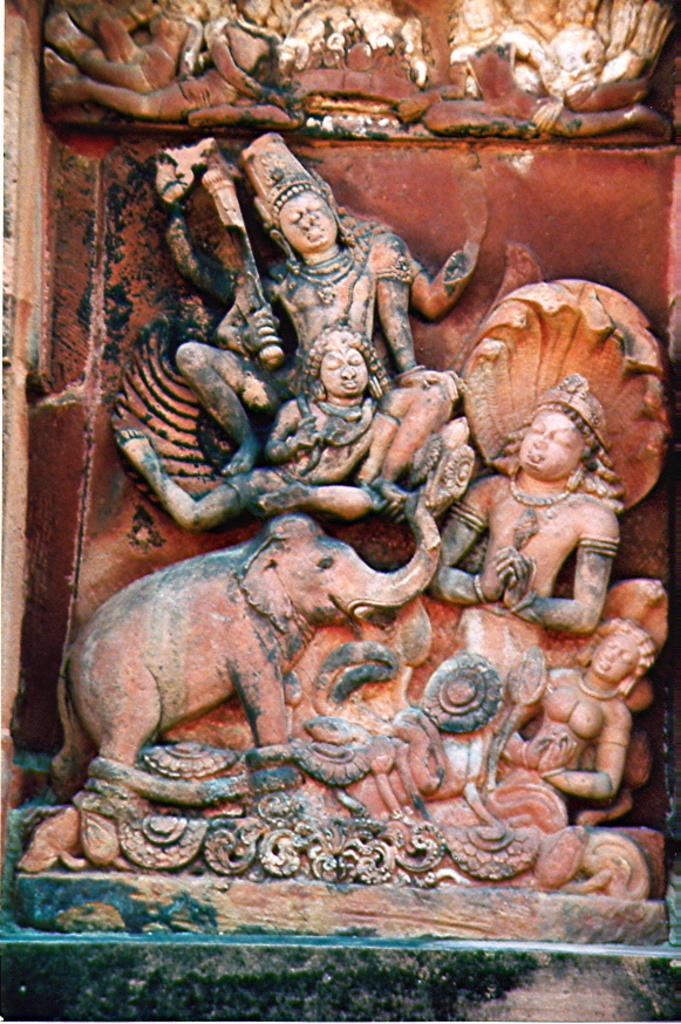How would you summarize this image in a sentence or two? In this image I can see a carved stone of idols. 